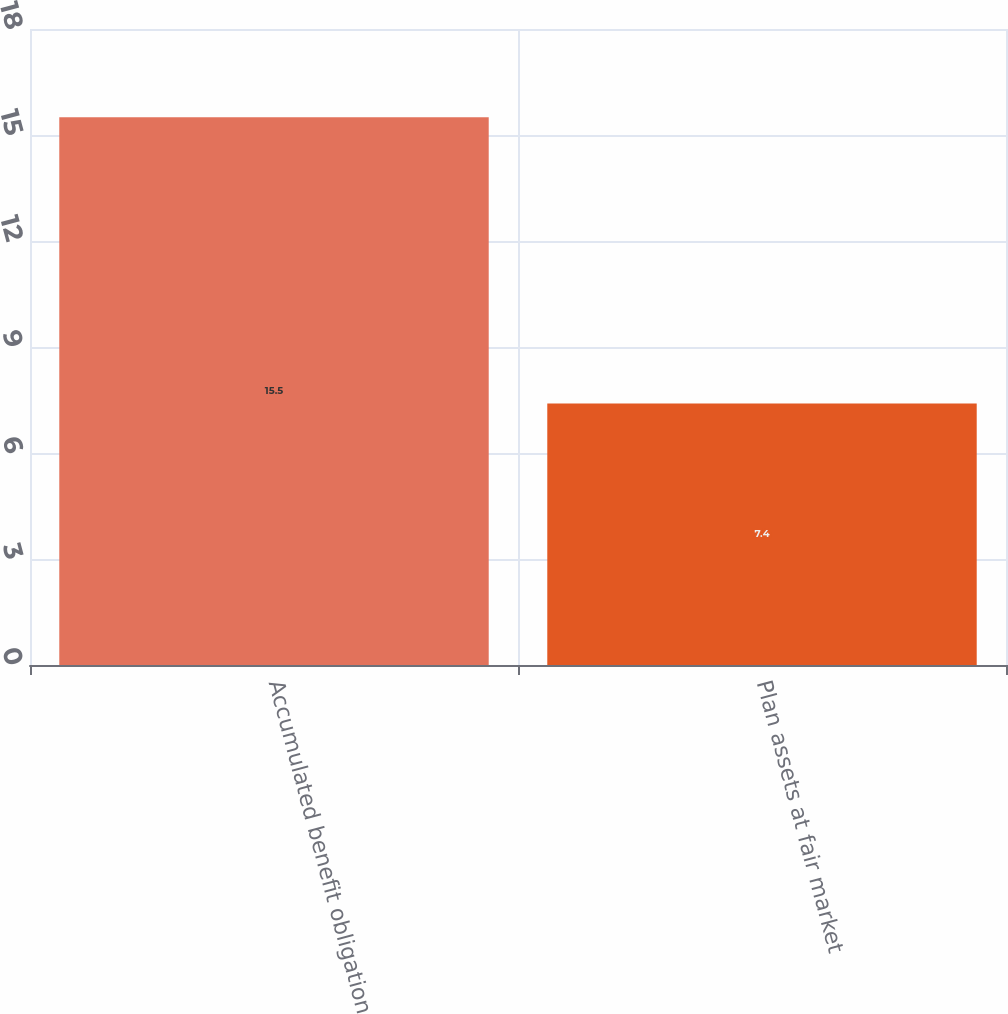<chart> <loc_0><loc_0><loc_500><loc_500><bar_chart><fcel>Accumulated benefit obligation<fcel>Plan assets at fair market<nl><fcel>15.5<fcel>7.4<nl></chart> 